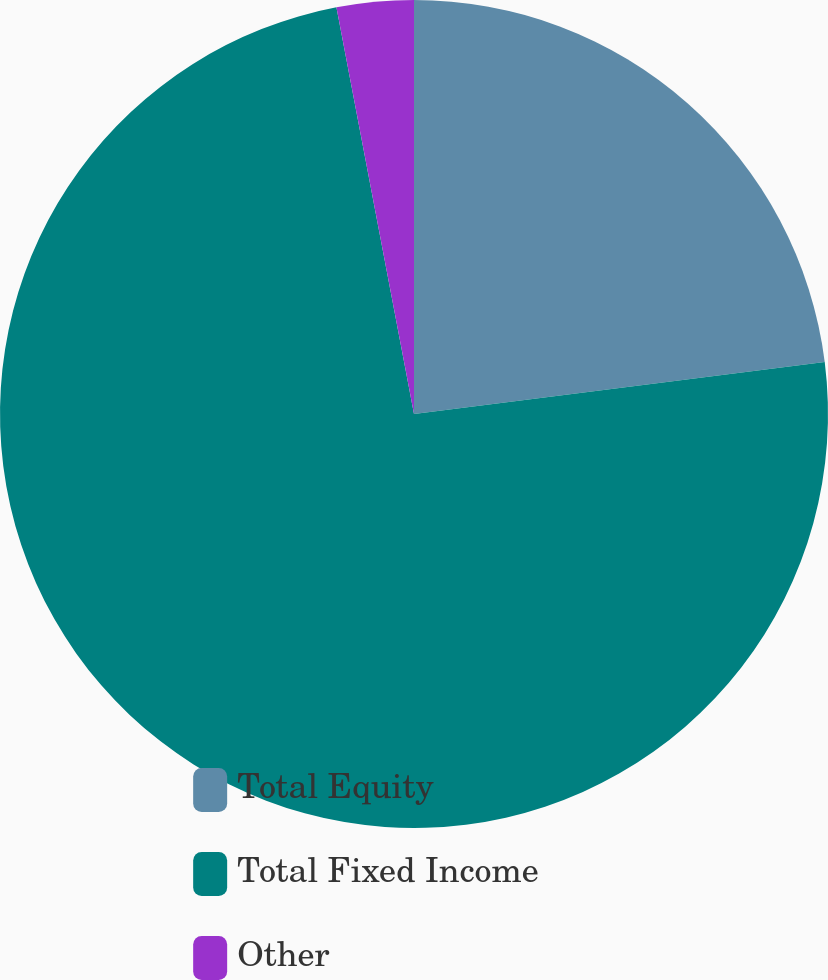Convert chart. <chart><loc_0><loc_0><loc_500><loc_500><pie_chart><fcel>Total Equity<fcel>Total Fixed Income<fcel>Other<nl><fcel>23.0%<fcel>74.0%<fcel>3.0%<nl></chart> 